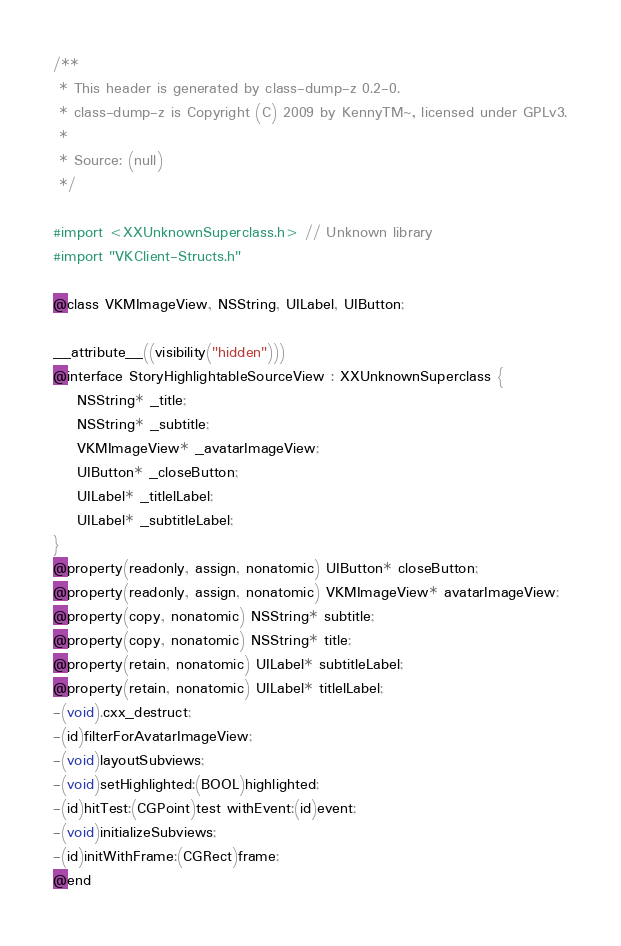<code> <loc_0><loc_0><loc_500><loc_500><_C_>/**
 * This header is generated by class-dump-z 0.2-0.
 * class-dump-z is Copyright (C) 2009 by KennyTM~, licensed under GPLv3.
 *
 * Source: (null)
 */

#import <XXUnknownSuperclass.h> // Unknown library
#import "VKClient-Structs.h"

@class VKMImageView, NSString, UILabel, UIButton;

__attribute__((visibility("hidden")))
@interface StoryHighlightableSourceView : XXUnknownSuperclass {
	NSString* _title;
	NSString* _subtitle;
	VKMImageView* _avatarImageView;
	UIButton* _closeButton;
	UILabel* _titlelLabel;
	UILabel* _subtitleLabel;
}
@property(readonly, assign, nonatomic) UIButton* closeButton;
@property(readonly, assign, nonatomic) VKMImageView* avatarImageView;
@property(copy, nonatomic) NSString* subtitle;
@property(copy, nonatomic) NSString* title;
@property(retain, nonatomic) UILabel* subtitleLabel;
@property(retain, nonatomic) UILabel* titlelLabel;
-(void).cxx_destruct;
-(id)filterForAvatarImageView;
-(void)layoutSubviews;
-(void)setHighlighted:(BOOL)highlighted;
-(id)hitTest:(CGPoint)test withEvent:(id)event;
-(void)initializeSubviews;
-(id)initWithFrame:(CGRect)frame;
@end

</code> 